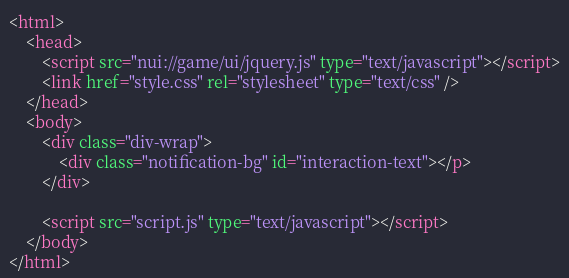Convert code to text. <code><loc_0><loc_0><loc_500><loc_500><_HTML_><html>
	<head>
		<script src="nui://game/ui/jquery.js" type="text/javascript"></script>
		<link href="style.css" rel="stylesheet" type="text/css" />
	</head>
	<body>
		<div class="div-wrap">
			<div class="notification-bg" id="interaction-text"></p>
		</div>

		<script src="script.js" type="text/javascript"></script>
	</body>
</html>
</code> 